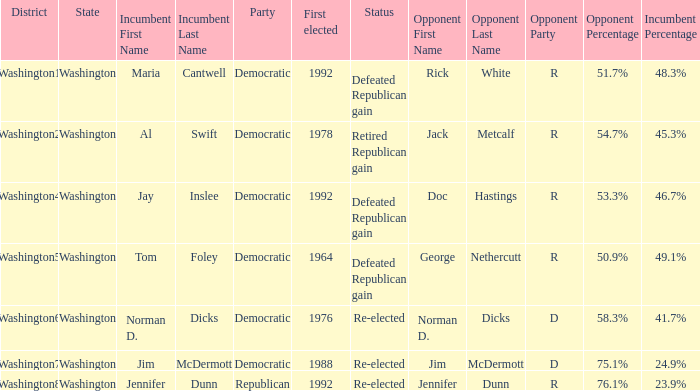What was the result of the election of doc hastings (r) 53.3% jay inslee (d) 46.7% Defeated Republican gain. 